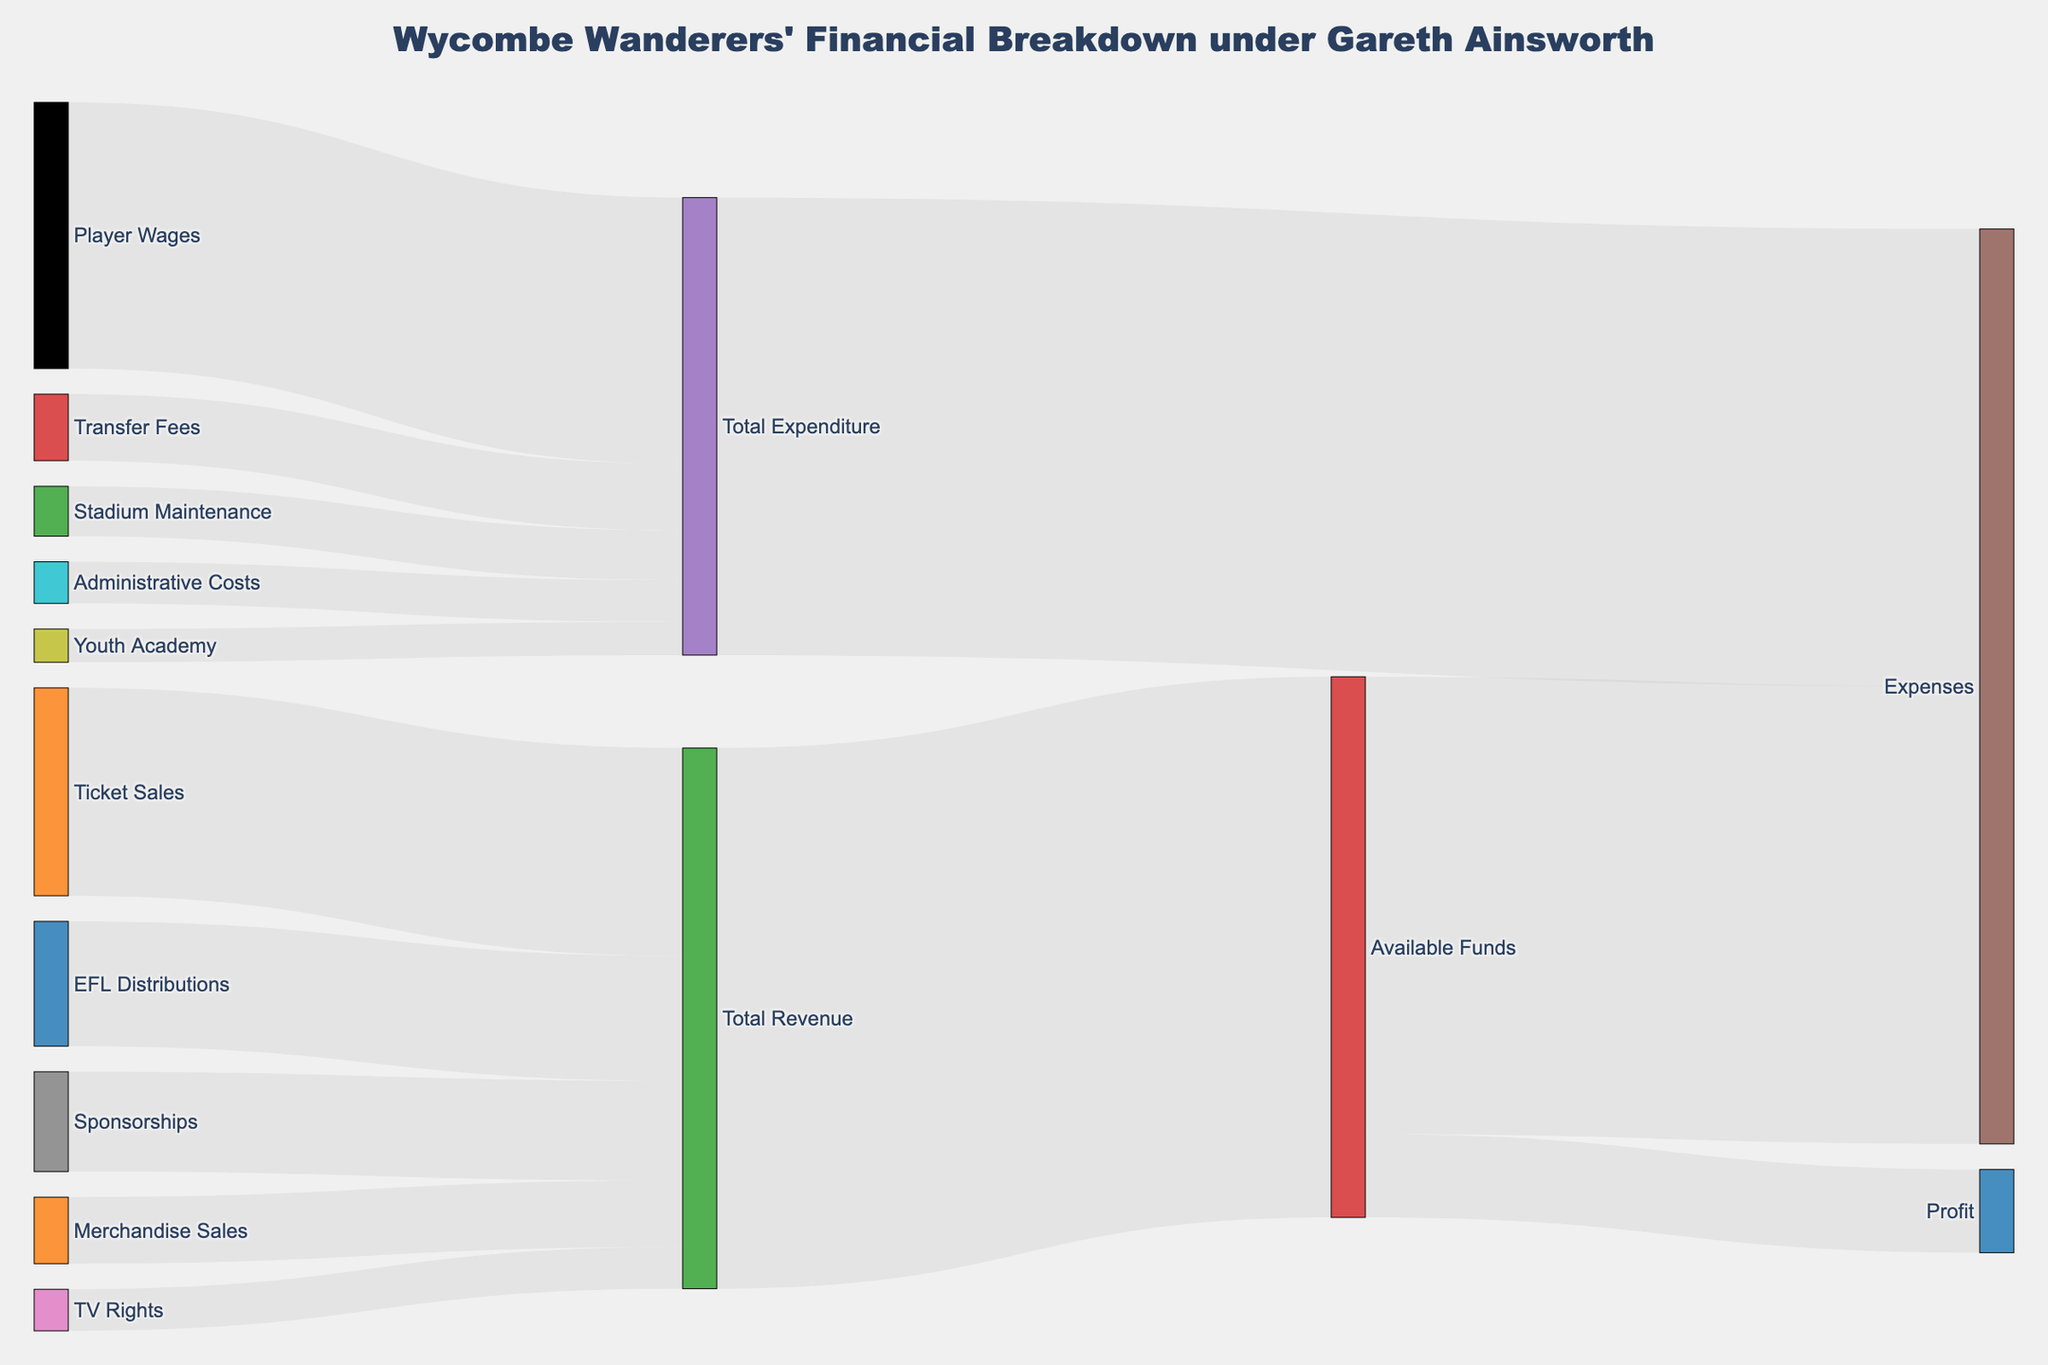What is the total revenue from ticket sales? The figure shows that ticket sales contribute a portion towards the total revenue. By following the flow from 'Ticket Sales' to 'Total Revenue', the value is clearly indicated.
Answer: 2,500,000 What is the amount spent on player wages? The figure illustrates the expenditures by Wycombe Wanderers. By tracing the flow from 'Player Wages' to 'Total Expenditure', the value is provided.
Answer: 3,200,000 How much profit does Wycombe Wanderers generate? The figure represents all financial flows, including the final profit. By following the flow from 'Available Funds' to 'Profit', the amount is visible.
Answer: 1,000,000 What is the combined contribution of merchandise sales and sponsorships to the total revenue? To calculate, sum up the values of flows from 'Merchandise Sales' and 'Sponsorships' to 'Total Revenue'. These values are from the merchandise sales (800,000) and sponsorships (1,200,000).
Answer: 2,000,000 Which has a higher value, administrative costs or stadium maintenance? By comparing the flows from 'Administrative Costs' and 'Stadium Maintenance' to 'Total Expenditure', it is clear which is greater. Administrative costs (500,000) are compared to stadium maintenance (600,000).
Answer: Stadium Maintenance What is the total expenditure? The figure shows the total expenditure connecting to the expenses. By following the flow from 'Total Expenditure' to 'Expenses', the value is given.
Answer: 5,500,000 Out of the total available funds, how much was allocated to expenses? To find out, look at the flow from 'Available Funds' to 'Expenses', which provides this allocation amount.
Answer: 5,500,000 What percentage of the total revenue comes from TV rights? First recognize that the total revenue is 6,500,000 as shown in the flows. Divide the 'TV Rights' revenue (500,000) by total revenue and multiply by 100 to get the percentage. Calculated as (500,000 / 6,500,000) * 100%.
Answer: 7.69% Compare the combined value of youth academy and transfer fees against player wages. Which is higher? First, sum the values from 'Youth Academy' (400,000) and 'Transfer Fees' (800,000), resulting in 1,200,000. Then, compare this sum to 'Player Wages' (3,200,000).
Answer: Player Wages Is the amount generated from EFL distributions higher than that from sponsorships? Compare the flows from 'EFL Distributions' (1,500,000) and 'Sponsorships' (1,200,000) to 'Total Revenue'.
Answer: Yes 